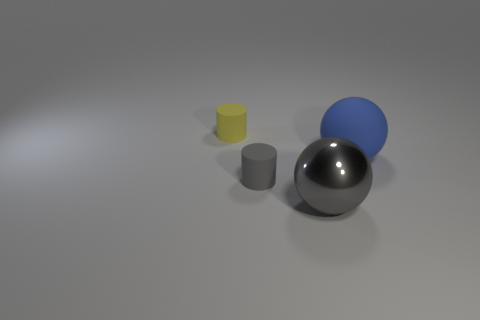Add 4 big blue rubber cylinders. How many objects exist? 8 Add 4 big blue spheres. How many big blue spheres exist? 5 Subtract 0 blue cylinders. How many objects are left? 4 Subtract all large brown cubes. Subtract all gray cylinders. How many objects are left? 3 Add 3 gray matte things. How many gray matte things are left? 4 